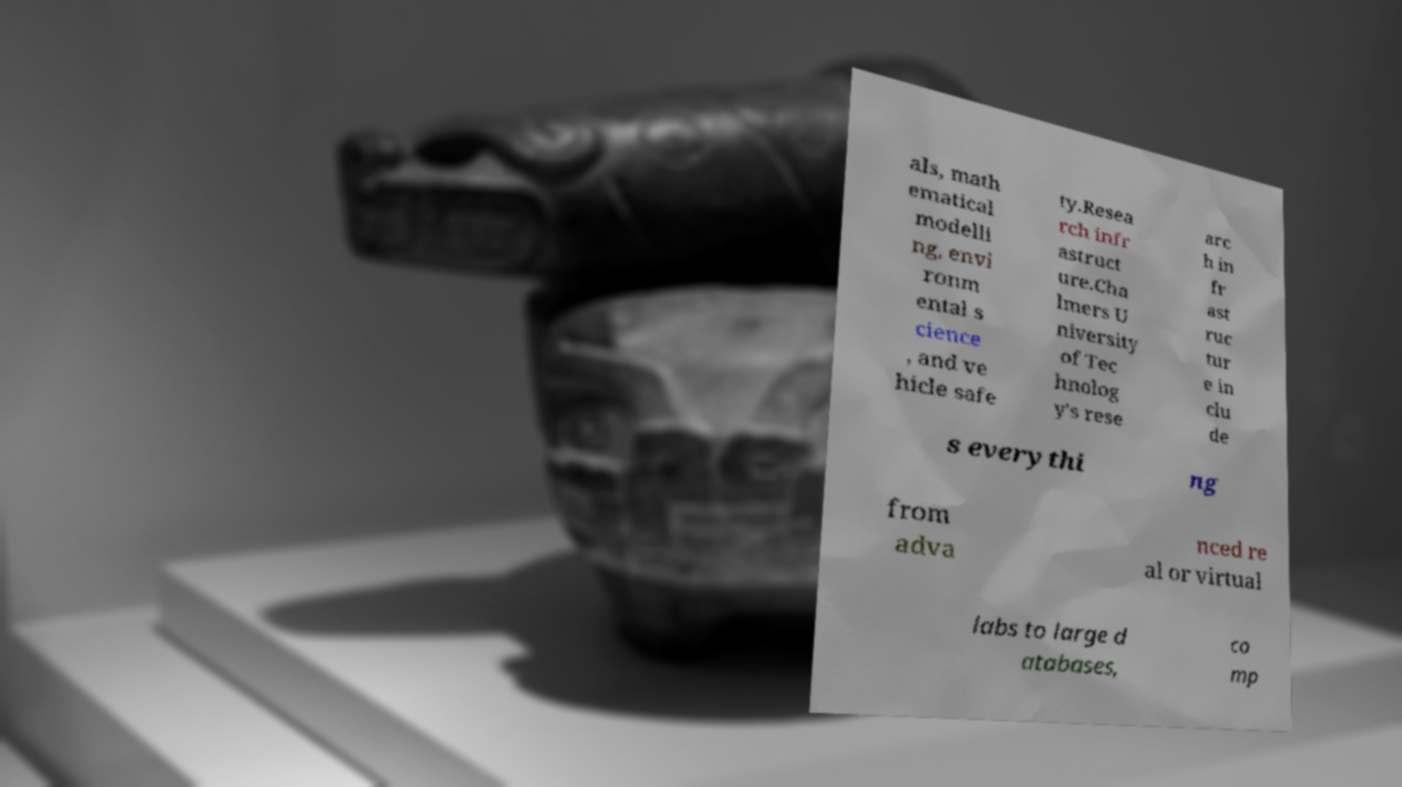Could you assist in decoding the text presented in this image and type it out clearly? als, math ematical modelli ng, envi ronm ental s cience , and ve hicle safe ty.Resea rch infr astruct ure.Cha lmers U niversity of Tec hnolog y's rese arc h in fr ast ruc tur e in clu de s everythi ng from adva nced re al or virtual labs to large d atabases, co mp 